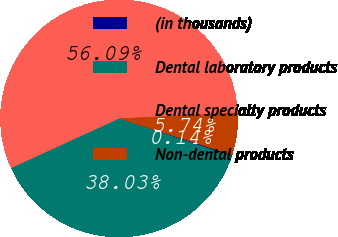Convert chart to OTSL. <chart><loc_0><loc_0><loc_500><loc_500><pie_chart><fcel>(in thousands)<fcel>Dental laboratory products<fcel>Dental specialty products<fcel>Non-dental products<nl><fcel>0.14%<fcel>38.03%<fcel>56.09%<fcel>5.74%<nl></chart> 